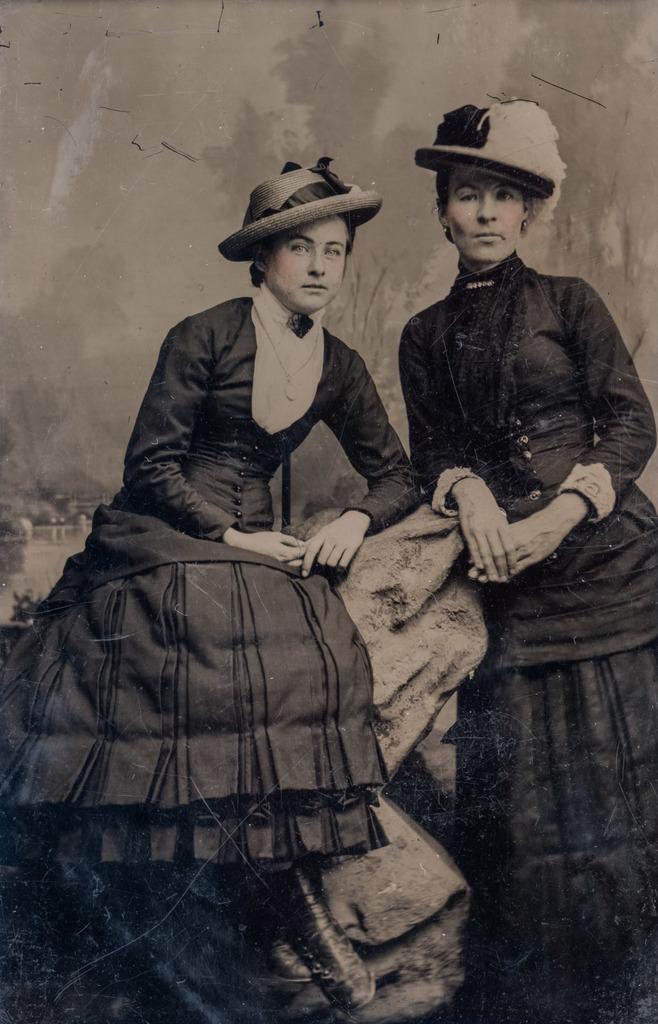Please provide a concise description of this image. In the image we can see there are two people wearing clothes and hat, this person is sitting and the other one is standing, this is a neck chain. 